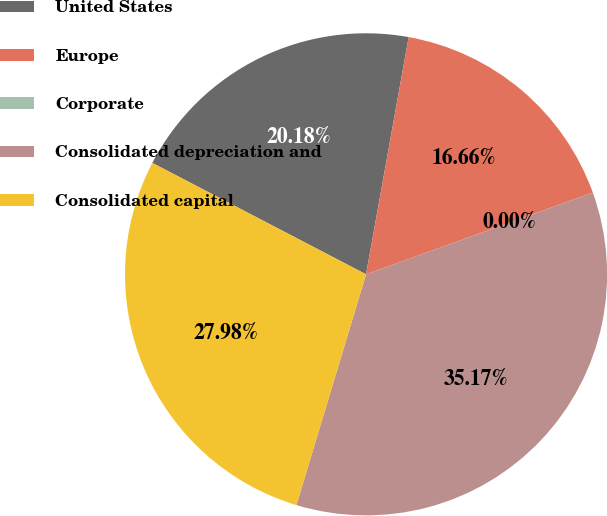Convert chart to OTSL. <chart><loc_0><loc_0><loc_500><loc_500><pie_chart><fcel>United States<fcel>Europe<fcel>Corporate<fcel>Consolidated depreciation and<fcel>Consolidated capital<nl><fcel>20.18%<fcel>16.66%<fcel>0.0%<fcel>35.17%<fcel>27.98%<nl></chart> 